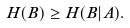Convert formula to latex. <formula><loc_0><loc_0><loc_500><loc_500>H ( B ) \geq H ( B | A ) .</formula> 